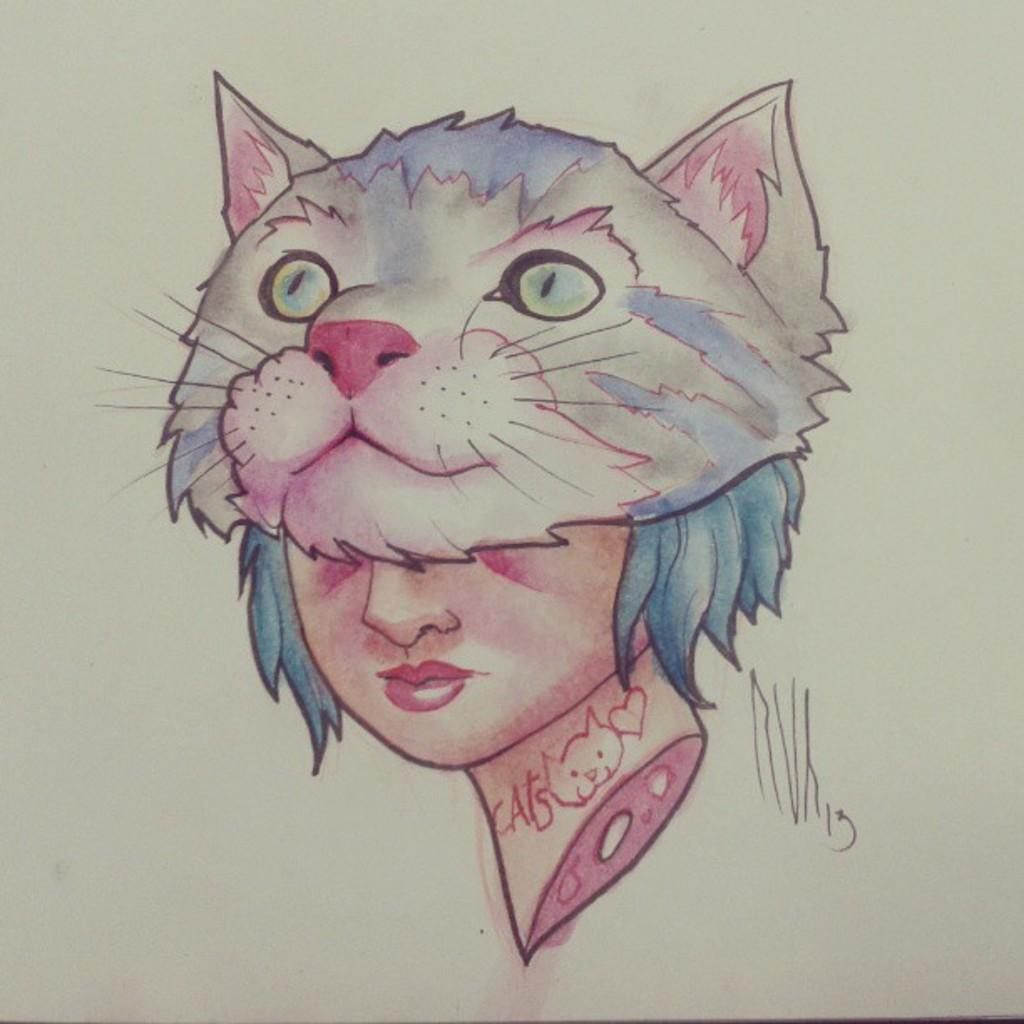What is present on the paper in the image? The paper contains a colorful drawing. What is the subject of the drawing? The drawing depicts a cat face and a woman. What can be inferred about the style or technique used in the drawing? The drawing is colorful, suggesting the use of bright colors or markers. What month is featured on the calendar in the image? There is no calendar present in the image; it only contains a paper with a colorful drawing. How does the drawing promote harmony between different species? The drawing does not depict any interaction between different species, nor does it promote harmony; it simply shows a cat face and a woman. 